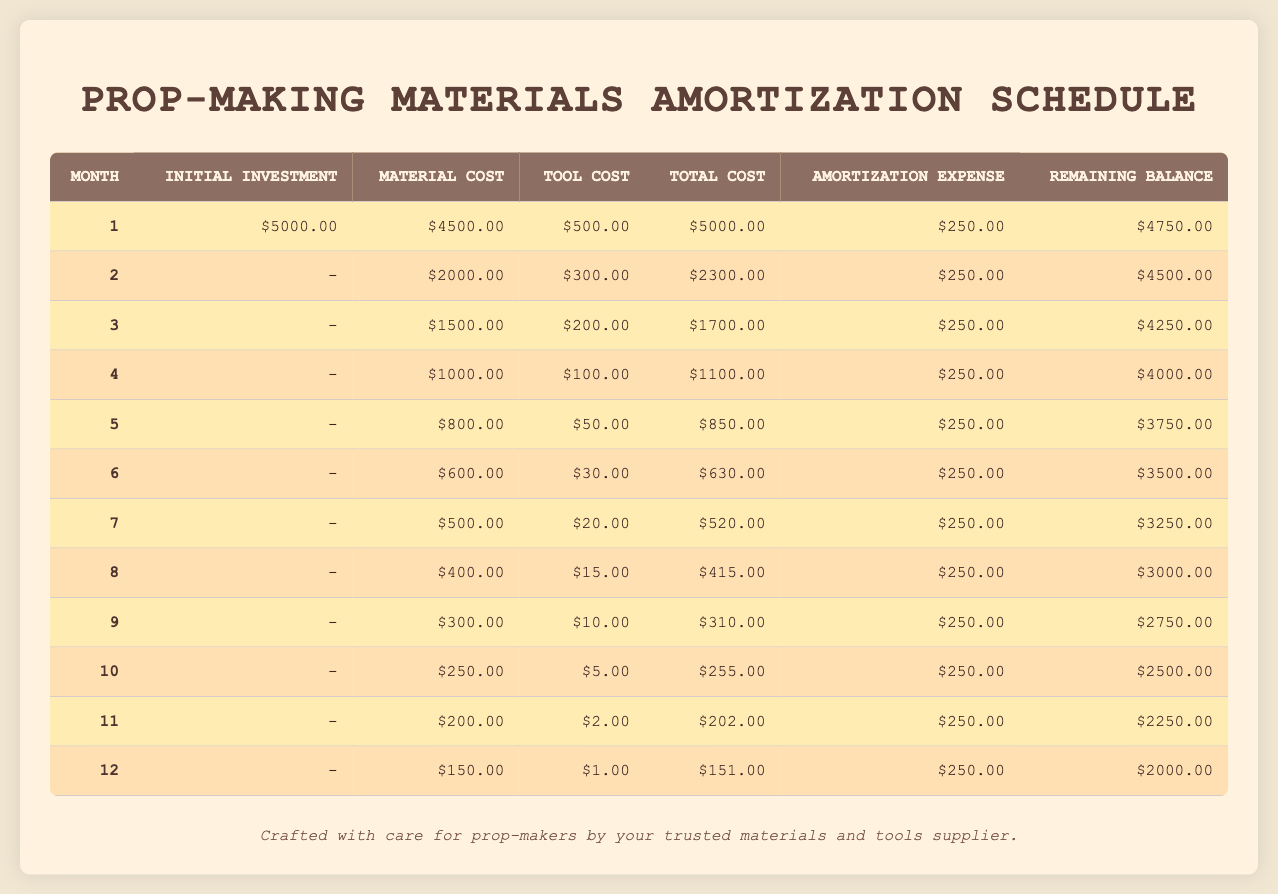What is the total cost for month 3? In month 3, the total cost is listed in the table under the "Total Cost" column, which shows 1700.
Answer: 1700 What was the amortization expense for the first month? The amortization expense for the first month can be found in the "Amortization Expense" column for month 1, and it shows 250.
Answer: 250 Is the remaining balance greater than 3000 after month 7? To assess this, we look at the "Remaining Balance" for month 7, which is 3250. Since 3250 is greater than 3000, the statement is true.
Answer: Yes What is the average material cost over the first six months? We first sum the material costs for the first six months: 4500 + 2000 + 1500 + 1000 + 800 + 600 = 10300. Then, we divide by 6 (the number of months), which gives us 10300 / 6 = 1716.67.
Answer: 1716.67 How does the total cost change from month 1 to month 12? The total cost for month 1 is 5000, and for month 12 it is 151. Subtracting the two gives us a change of 5000 - 151 = 4849. This indicates a decrease.
Answer: Decrease of 4849 What month has the lowest total cost, and what is that cost? By examining the "Total Cost" column for all months, the minimum value occurs in month 12, with a total cost of 151.
Answer: Month 12, cost 151 Is the amortization expense consistent throughout the year? By checking the "Amortization Expense" column for all months, we see that it remains constant at 250 across all months, so it is consistent.
Answer: Yes What is the total remaining balance after 6 months? At the end of month 6, the remaining balance is 3500 as directly seen in the table.
Answer: 3500 What was the material cost incurred in month 9? For month 9, the material cost listed in the table is 300.
Answer: 300 